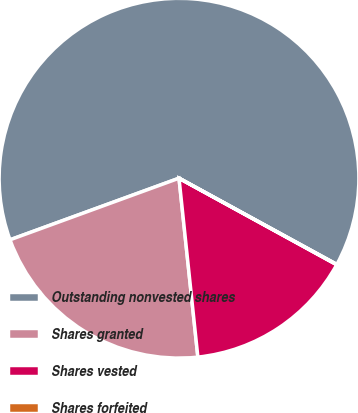Convert chart. <chart><loc_0><loc_0><loc_500><loc_500><pie_chart><fcel>Outstanding nonvested shares<fcel>Shares granted<fcel>Shares vested<fcel>Shares forfeited<nl><fcel>63.52%<fcel>21.11%<fcel>15.34%<fcel>0.03%<nl></chart> 